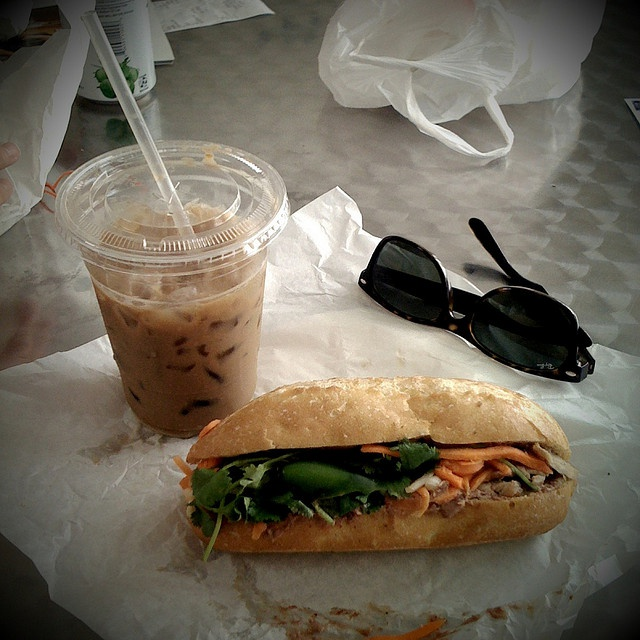Describe the objects in this image and their specific colors. I can see dining table in black, gray, and darkgray tones, sandwich in black, maroon, and tan tones, hot dog in black, maroon, and tan tones, and cup in black, darkgray, gray, and maroon tones in this image. 